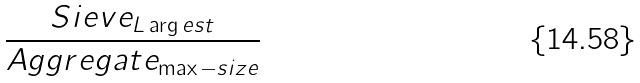Convert formula to latex. <formula><loc_0><loc_0><loc_500><loc_500>\frac { S i e v e _ { L \arg e s t } } { A g g r e g a t e _ { \max - s i z e } }</formula> 